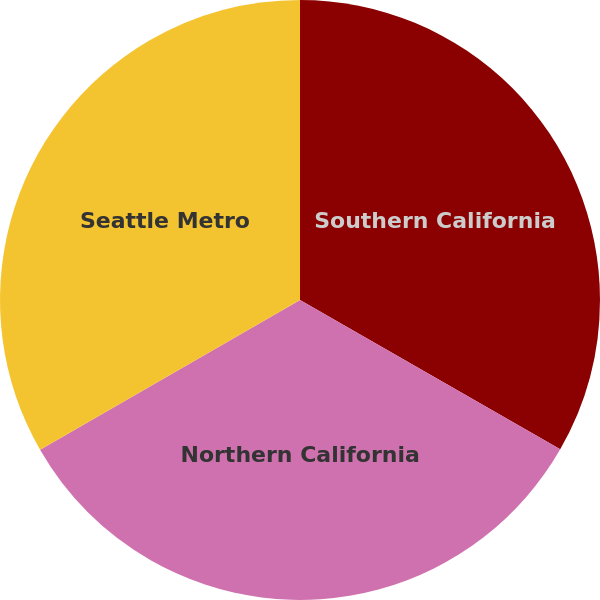Convert chart. <chart><loc_0><loc_0><loc_500><loc_500><pie_chart><fcel>Southern California<fcel>Northern California<fcel>Seattle Metro<nl><fcel>33.29%<fcel>33.39%<fcel>33.32%<nl></chart> 